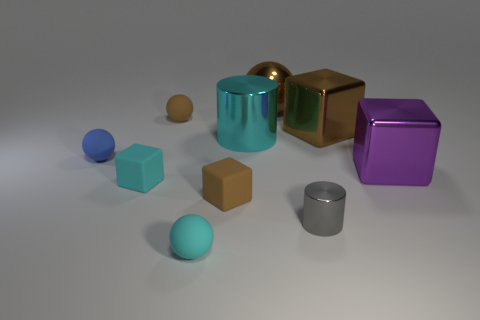Is there any other thing that is the same size as the blue sphere? Regarding objects similar in size to the blue sphere, there are a couple that appear to be roughly comparable. For instance, the tan cube and the small orange sphere might be of similar dimensions, though without exact measurements, it's difficult to ascertain precision in size matching. However, for a more accurate comparison, tools like a ruler or reference scale would be necessary. 